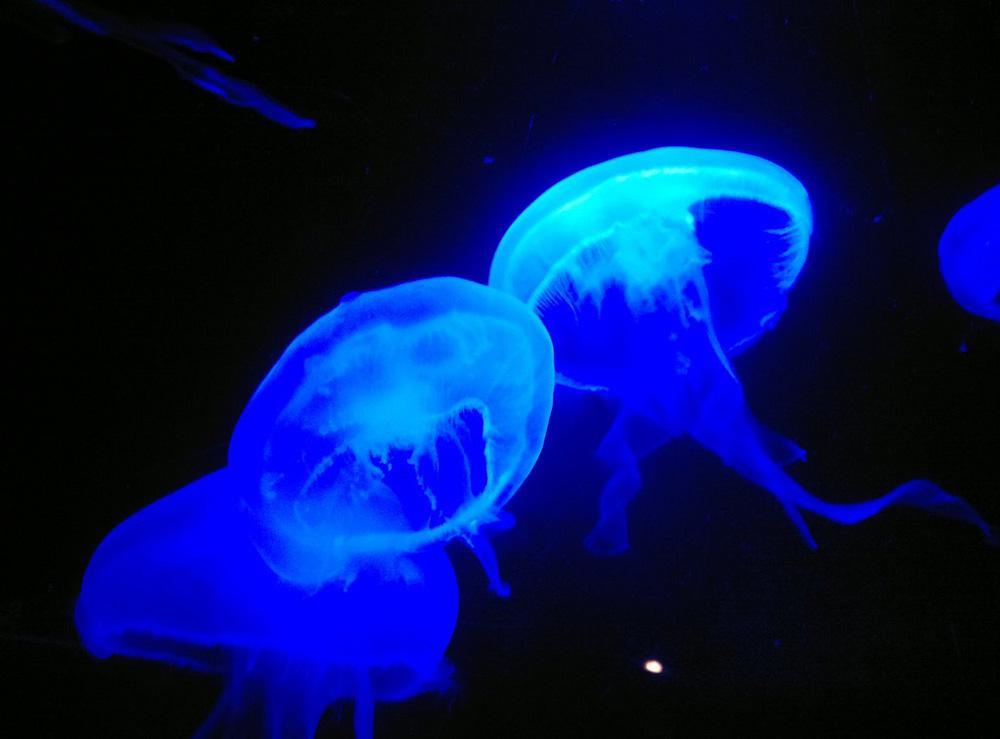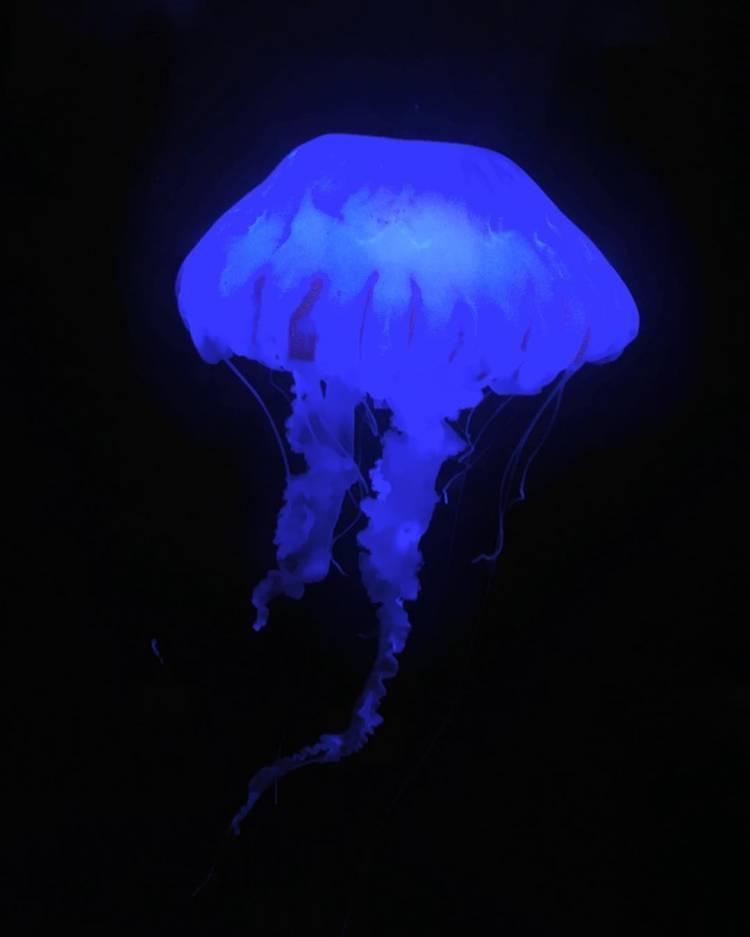The first image is the image on the left, the second image is the image on the right. Given the left and right images, does the statement "multiple columned aquariums are holding jellyfish" hold true? Answer yes or no. No. The first image is the image on the left, the second image is the image on the right. Given the left and right images, does the statement "An aquarium consists of multiple well lit geometrical shaped enclosures that have many types of sea creatures inside." hold true? Answer yes or no. No. 